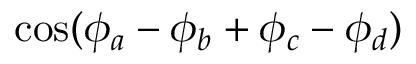<formula> <loc_0><loc_0><loc_500><loc_500>{ \cos ( \phi _ { a } - \phi _ { b } + \phi _ { c } - \phi _ { d } ) }</formula> 